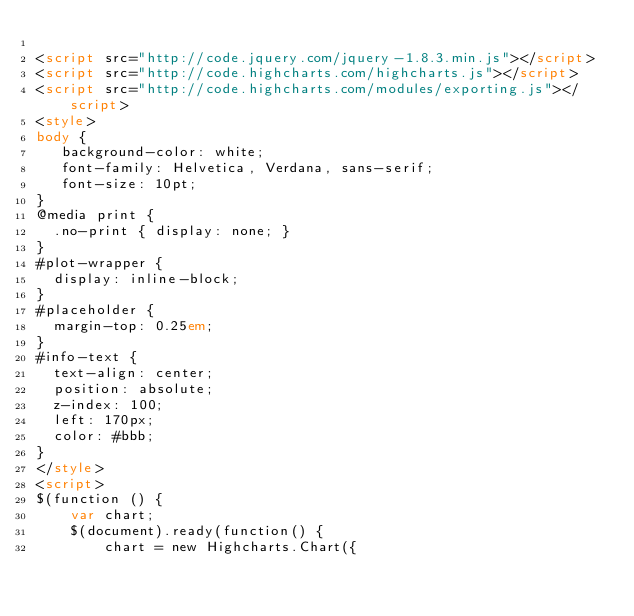<code> <loc_0><loc_0><loc_500><loc_500><_HTML_>
<script src="http://code.jquery.com/jquery-1.8.3.min.js"></script>
<script src="http://code.highcharts.com/highcharts.js"></script>
<script src="http://code.highcharts.com/modules/exporting.js"></script>
<style>
body {
   background-color: white;
   font-family: Helvetica, Verdana, sans-serif;
   font-size: 10pt;
}
@media print {
  .no-print { display: none; }
}
#plot-wrapper {
  display: inline-block;
}
#placeholder {
  margin-top: 0.25em;
}
#info-text {
  text-align: center;
  position: absolute;
  z-index: 100;
  left: 170px;
  color: #bbb;
}
</style>
<script>
$(function () {
    var chart;
    $(document).ready(function() {
        chart = new Highcharts.Chart({</code> 